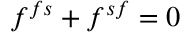<formula> <loc_0><loc_0><loc_500><loc_500>f ^ { f s } + f ^ { s f } = 0</formula> 